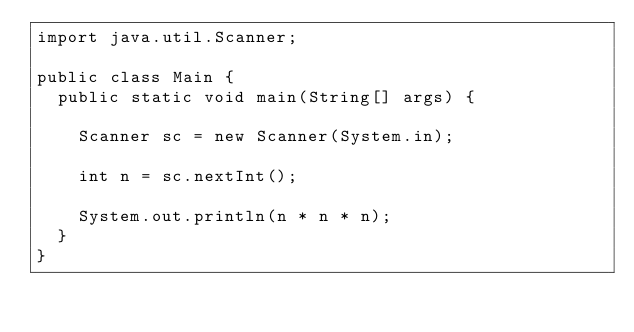Convert code to text. <code><loc_0><loc_0><loc_500><loc_500><_Java_>import java.util.Scanner;

public class Main {
  public static void main(String[] args) {

    Scanner sc = new Scanner(System.in);

    int n = sc.nextInt();
    
    System.out.println(n * n * n);
  }
}
</code> 